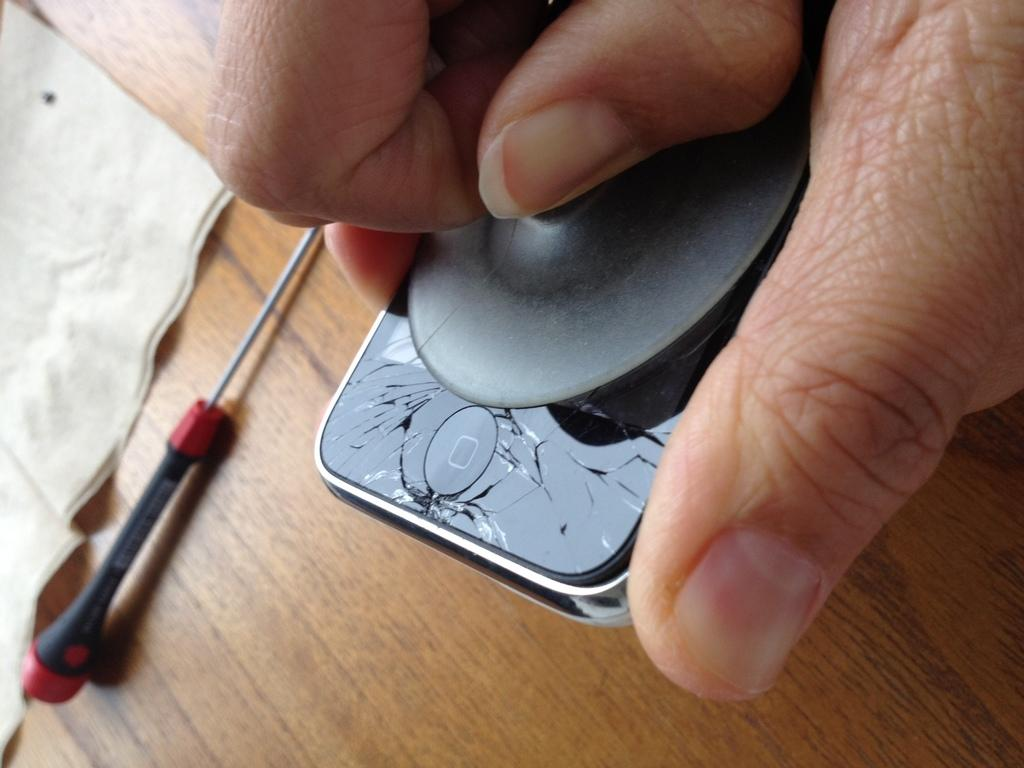Who is present in the image? There is a person in the image. What is the person holding? The person is holding a mobile. What can be seen in the background of the image? There is a table in the background of the image. What is on the table? There is paper and an object on the table. How many snakes are slithering across the table in the image? There are no snakes present in the image. What color is the sock on the person's foot in the image? There is no sock visible in the image. 